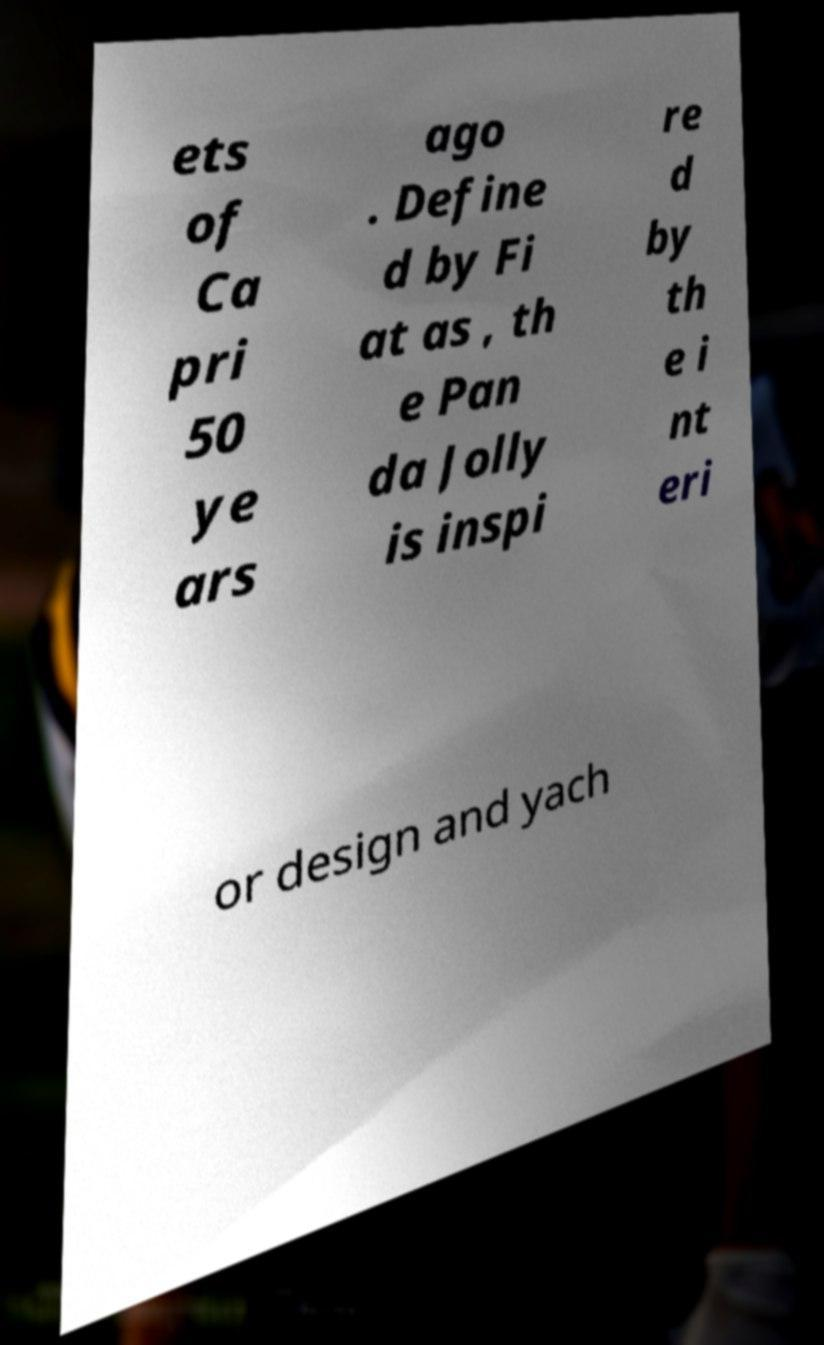For documentation purposes, I need the text within this image transcribed. Could you provide that? ets of Ca pri 50 ye ars ago . Define d by Fi at as , th e Pan da Jolly is inspi re d by th e i nt eri or design and yach 